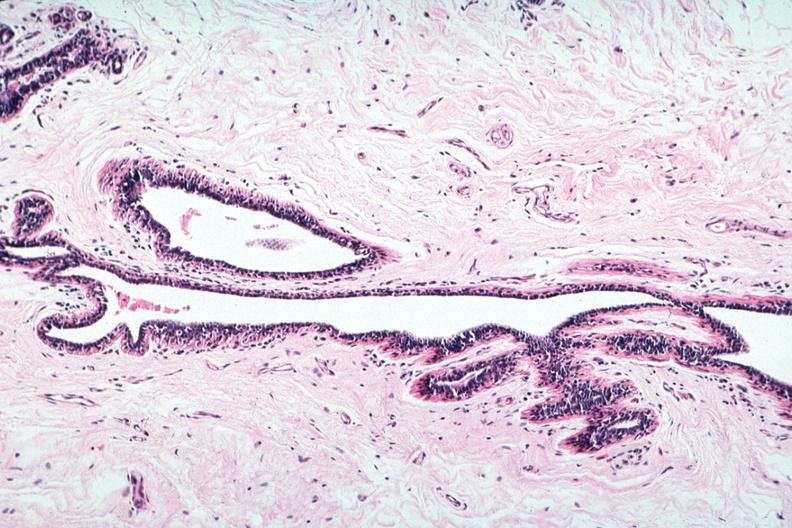s subdiaphragmatic abscess present?
Answer the question using a single word or phrase. No 